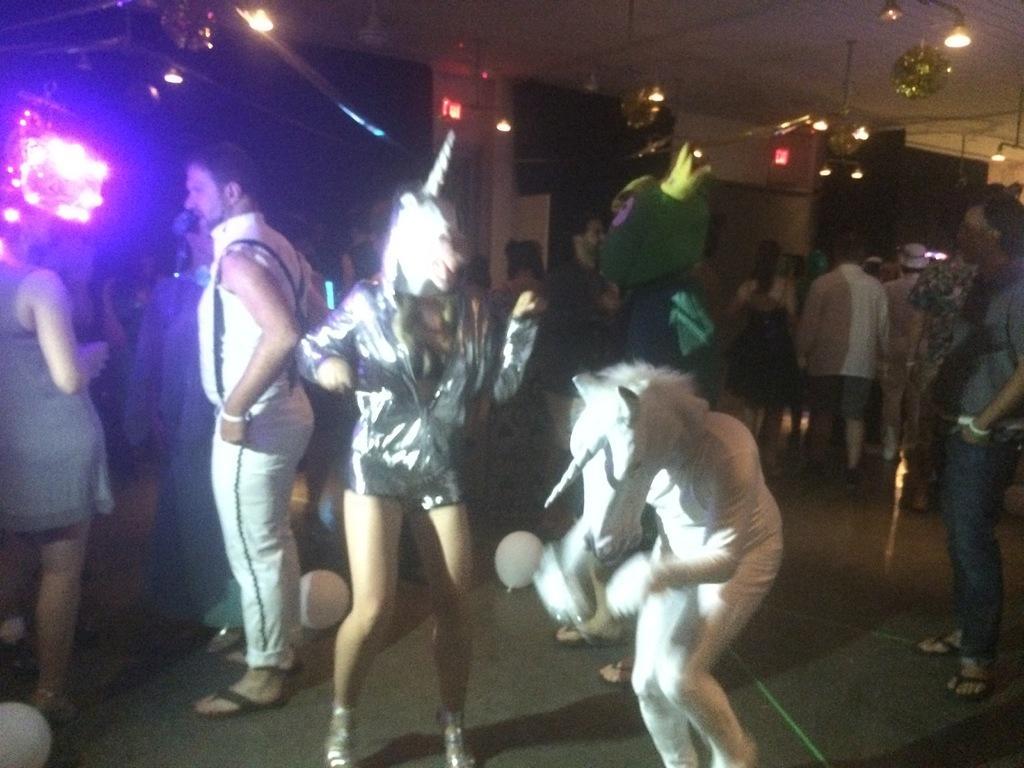Could you give a brief overview of what you see in this image? In this picture, we see three people wearing animal costume. Behind them, there are many people standing. At the top of the picture, we see the lights and the ceiling of the room. At the bottom, there are balloons in white color. This picture might be clicked in the party. 